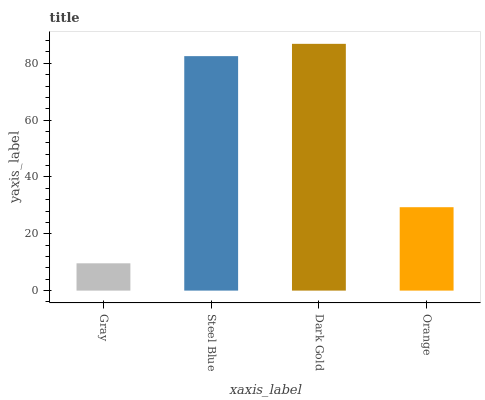Is Gray the minimum?
Answer yes or no. Yes. Is Dark Gold the maximum?
Answer yes or no. Yes. Is Steel Blue the minimum?
Answer yes or no. No. Is Steel Blue the maximum?
Answer yes or no. No. Is Steel Blue greater than Gray?
Answer yes or no. Yes. Is Gray less than Steel Blue?
Answer yes or no. Yes. Is Gray greater than Steel Blue?
Answer yes or no. No. Is Steel Blue less than Gray?
Answer yes or no. No. Is Steel Blue the high median?
Answer yes or no. Yes. Is Orange the low median?
Answer yes or no. Yes. Is Orange the high median?
Answer yes or no. No. Is Dark Gold the low median?
Answer yes or no. No. 